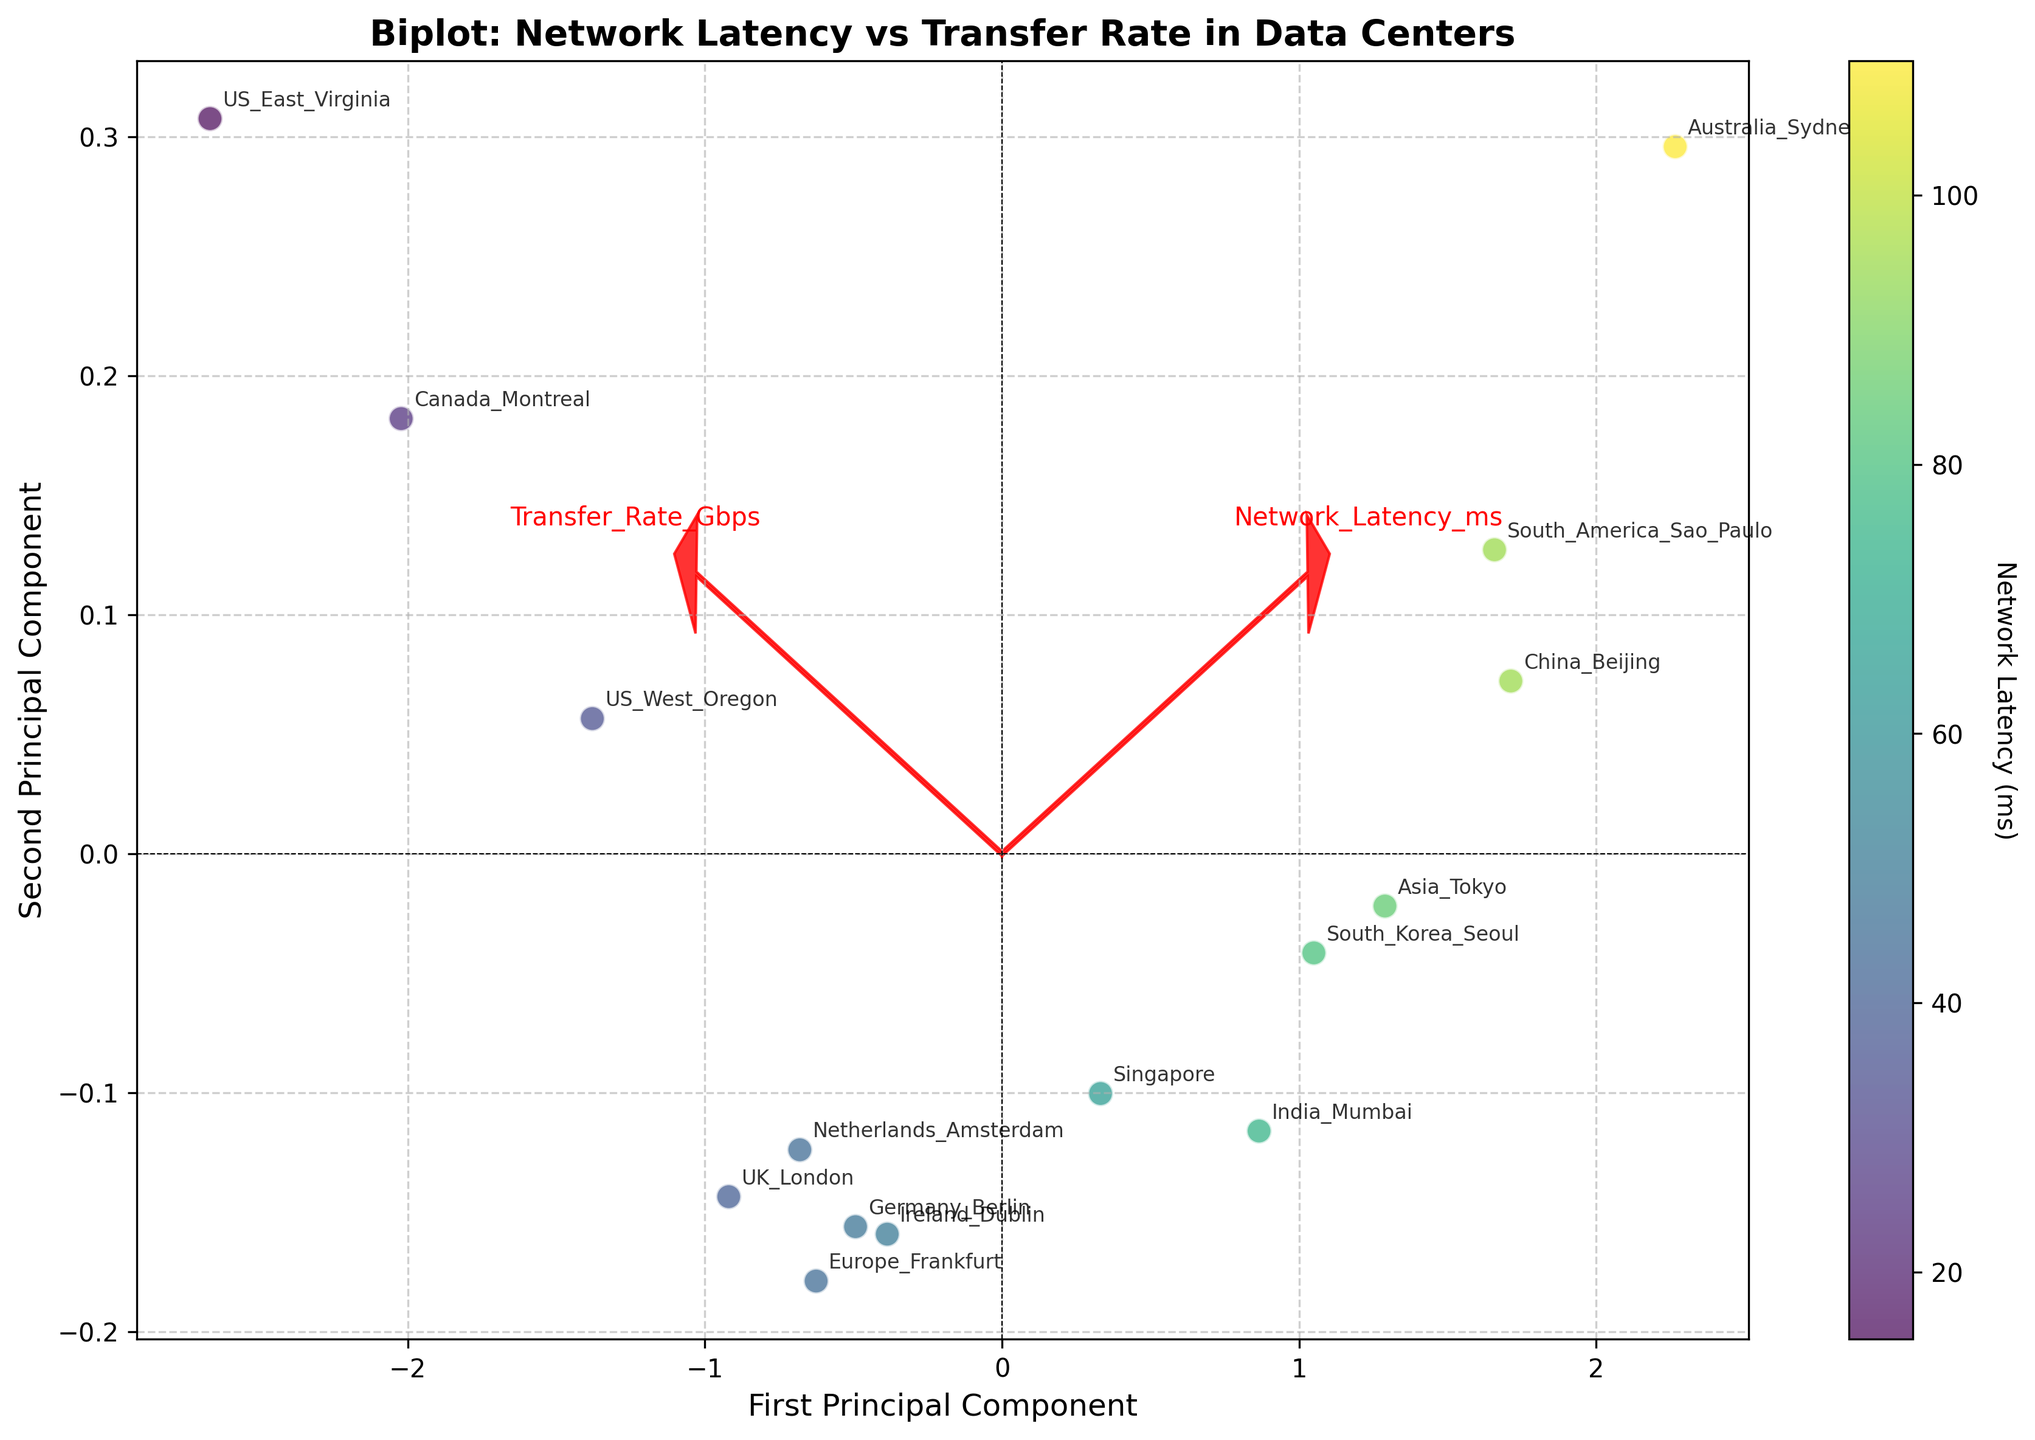What is the title of the figure? The title of the figure is prominently displayed at the top of the plot. It summarizes what the figure represents.
Answer: Biplot: Network Latency vs Transfer Rate in Data Centers What do the x and y axes represent in the figure? The labels on the x and y axes provide the information about what variables are being plotted. In this case, the axes are labeled respectively.
Answer: First Principal Component, Second Principal Component How many data points are shown in the figure? Each data point represents a data center. By counting the number of distinct points, or by referencing the length of the data set, you can determine the total number of points.
Answer: 15 Which data center has the highest network latency? The scatter plot uses a color gradient, with network latency reflected in the color intensity of the points. By identifying the darkest point (highest latency) and reading its label, you can find the answer.
Answer: Australia_Sydney Which data center has the highest transfer rate? Each point's position along the axes reflects its transfer rate. The further to one side (right) a point is, the higher the transfer rate. Identifying the right-most point will give the answer.
Answer: US_East_Virginia Is there any visible trend between network latency and transfer rates? By examining the general distribution and direction of the data points in the scatter plot, you can infer the relationship. If higher latencies correspond uniformly with lower transfer rates, it suggests a negative correlation.
Answer: Yes, there is a negative trend Which components are plotted as loading vectors in red arrows, and what do they represent? The red arrows represent loading vectors for the variables, and each arrow is labeled based on the variable it represents. These help to interpret the contribution of each variable to the principal components.
Answer: Network Latency (ms), Transfer Rate (Gbps) Do Asia_Tokyo and South_America_Sao_Paulo have similar network latencies and transfer rates? Comparing the positions and color gradients of the points labeled Asia_Tokyo and South_America_Sao_Paulo can tell you if they have similar network latencies and transfer rates.
Answer: Yes, similar Which regions have data centers with transfer rates between 4 and 5 Gbps and network latencies below 80 ms? By focusing on points within the specific color range for network latency (below a certain color threshold) and checking their locations along the axes for transfer rates between 4 and 5 Gbps, you can identify these regions.
Answer: Asia_Tokyo, South_Korea_Seoul Are there more data centers with high transfer rates (above 5.5 Gbps) or with low transfer rates (below 5.5 Gbps)? Counting the number of points that fall on either side of the 5.5 Gbps mark along the transfer rate axis will provide this answer.
Answer: More with low transfer rates 